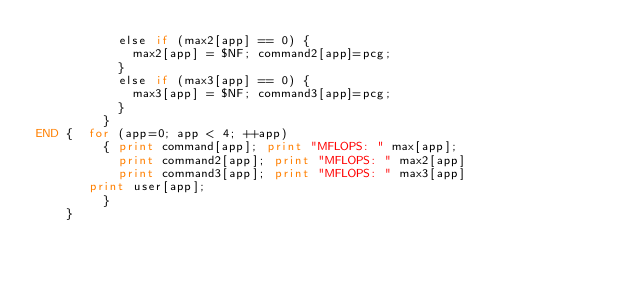Convert code to text. <code><loc_0><loc_0><loc_500><loc_500><_Awk_>           else if (max2[app] == 0) {
             max2[app] = $NF; command2[app]=pcg;
           }
           else if (max3[app] == 0) {
             max3[app] = $NF; command3[app]=pcg;
           }
         }
END {  for (app=0; app < 4; ++app)
         { print command[app]; print "MFLOPS: " max[app]; 
           print command2[app]; print "MFLOPS: " max2[app] 
           print command3[app]; print "MFLOPS: " max3[app] 
  	   print user[app];
         }
    }
</code> 